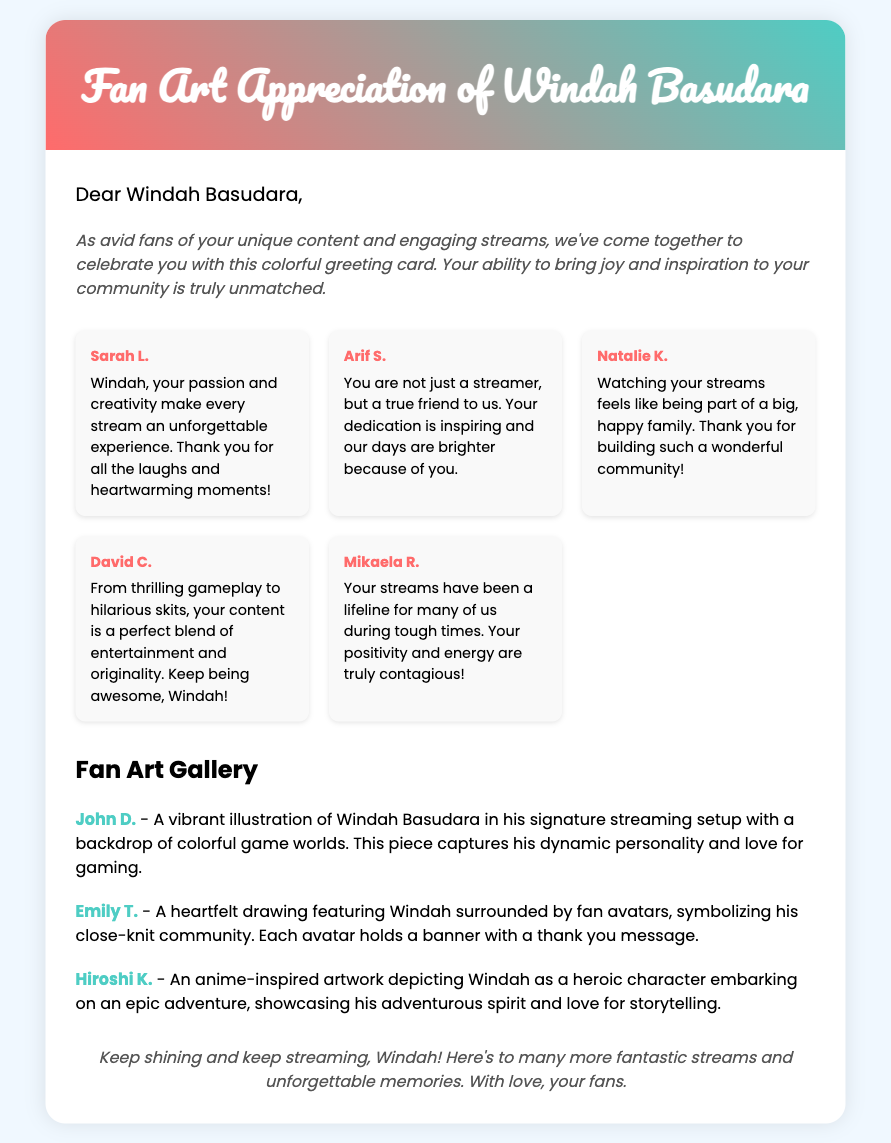what is the title of the greeting card? The title of the greeting card is prominently displayed in the header section of the document.
Answer: Fan Art Appreciation of Windah Basudara how many fan messages are included in the document? The document includes a list of messages from fans, which can be counted in the fan-messages section.
Answer: 5 who is the first fan mentioned in the messages? The first fan mentioned is listed as the first message in the fan messages section.
Answer: Sarah L what is the theme of the fan art by Hiroshi K.? Hiroshi K.'s fan art is described in a specific section dedicated to fan art, capturing a particular theme related to Windah.
Answer: Anime-inspired artwork what colors are used in the header background? The header section features a gradient background with specific colors that can be identified visually.
Answer: Red and teal what does the closing message express? The closing message summarizes the sentiment of the card and what it conveys to Windah, focusing on the overall tone and intention.
Answer: Keep shining and keep streaming who created the second fan art piece? The creator of the second fan art piece can be found in the description accompanying that specific artwork.
Answer: Emily T how does the introduction message describe Windah's content? The introduction message provides an overview of how Windah's content impacts his audience, reflecting a positive sentiment.
Answer: Unique and engaging 